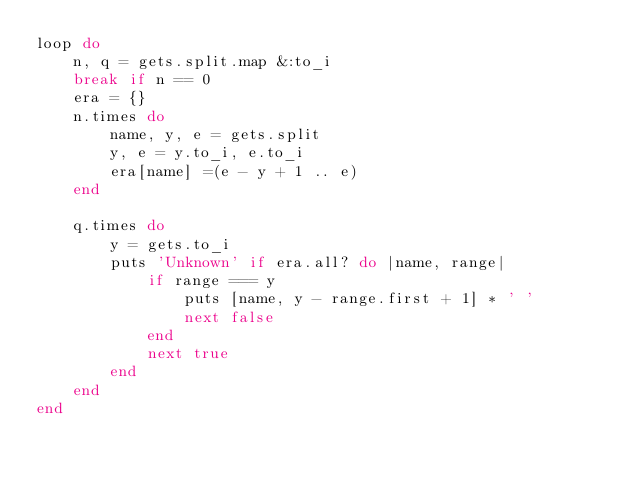<code> <loc_0><loc_0><loc_500><loc_500><_Ruby_>loop do
    n, q = gets.split.map &:to_i
    break if n == 0
    era = {}
    n.times do
        name, y, e = gets.split
        y, e = y.to_i, e.to_i
        era[name] =(e - y + 1 .. e)
    end 

    q.times do
        y = gets.to_i
        puts 'Unknown' if era.all? do |name, range|
            if range === y
                puts [name, y - range.first + 1] * ' ' 
                next false
            end
            next true
        end
    end 
end</code> 